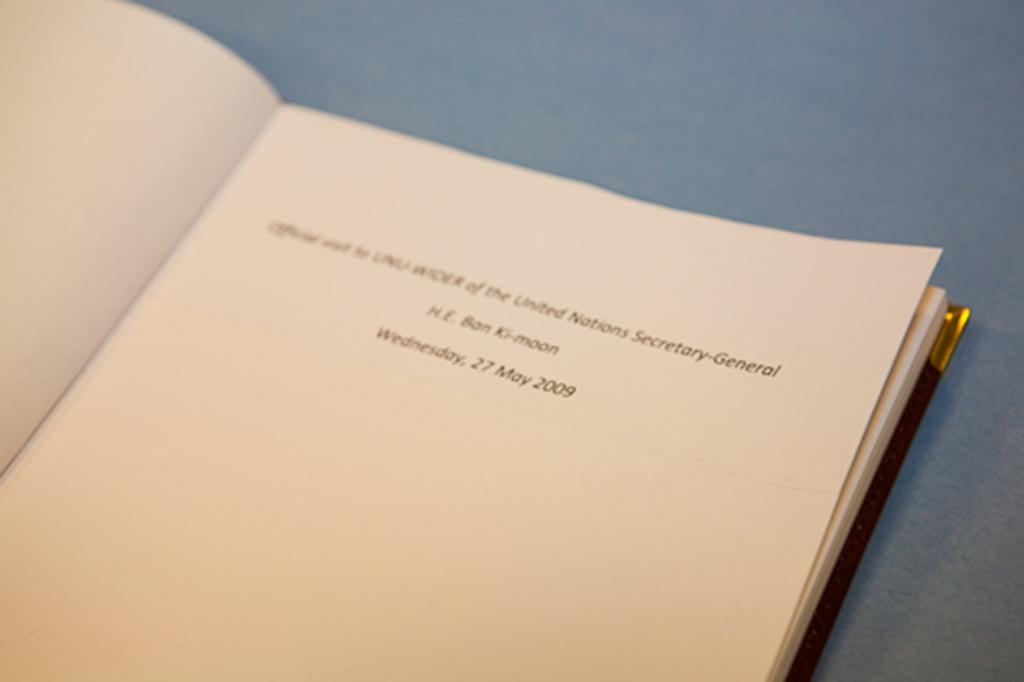<image>
Write a terse but informative summary of the picture. The first page of a journal belonging to Ban Ki-Moon indicating his position within the office of the United Nations Secretary-General. 